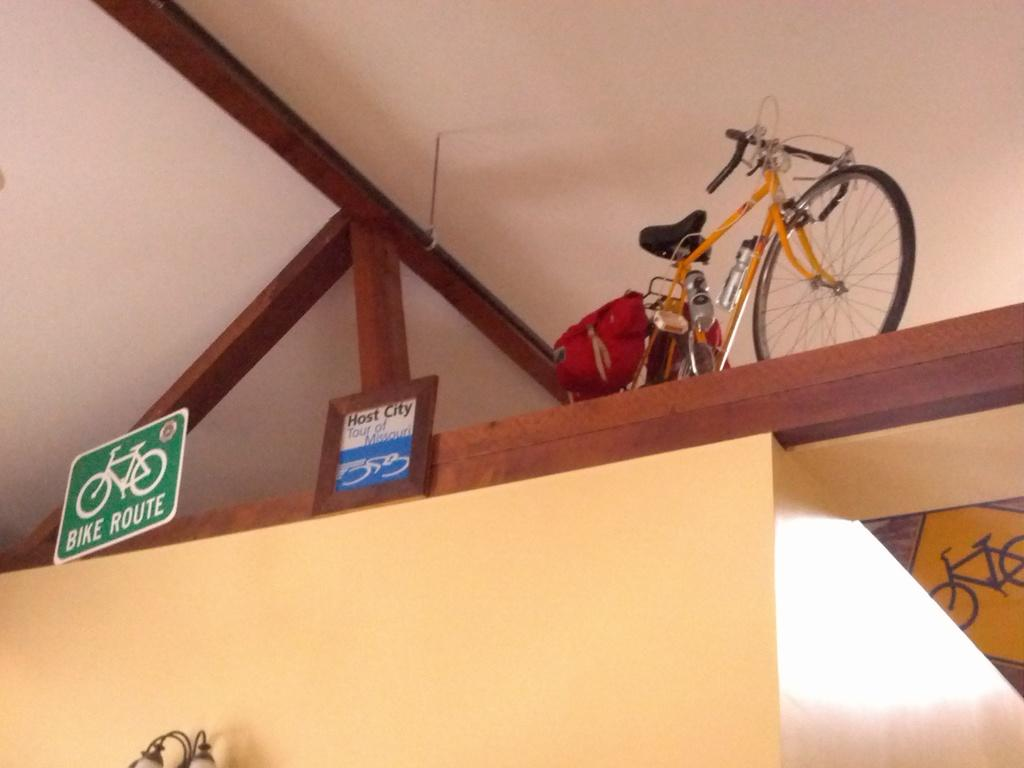What is the main object in the image? There is a bicycle in the image. What else can be seen besides the bicycle? There are two boards in the image. Can you describe one of the boards? One of the boards is green and has the text "BIKE RIDE" on it. What is the background of the image? There is a wall in the image. What else is present in the image? There are lights in the image. What type of mint is growing on the wall in the image? There is no mint plant visible in the image; it only features a bicycle, two boards, a wall, and lights. 